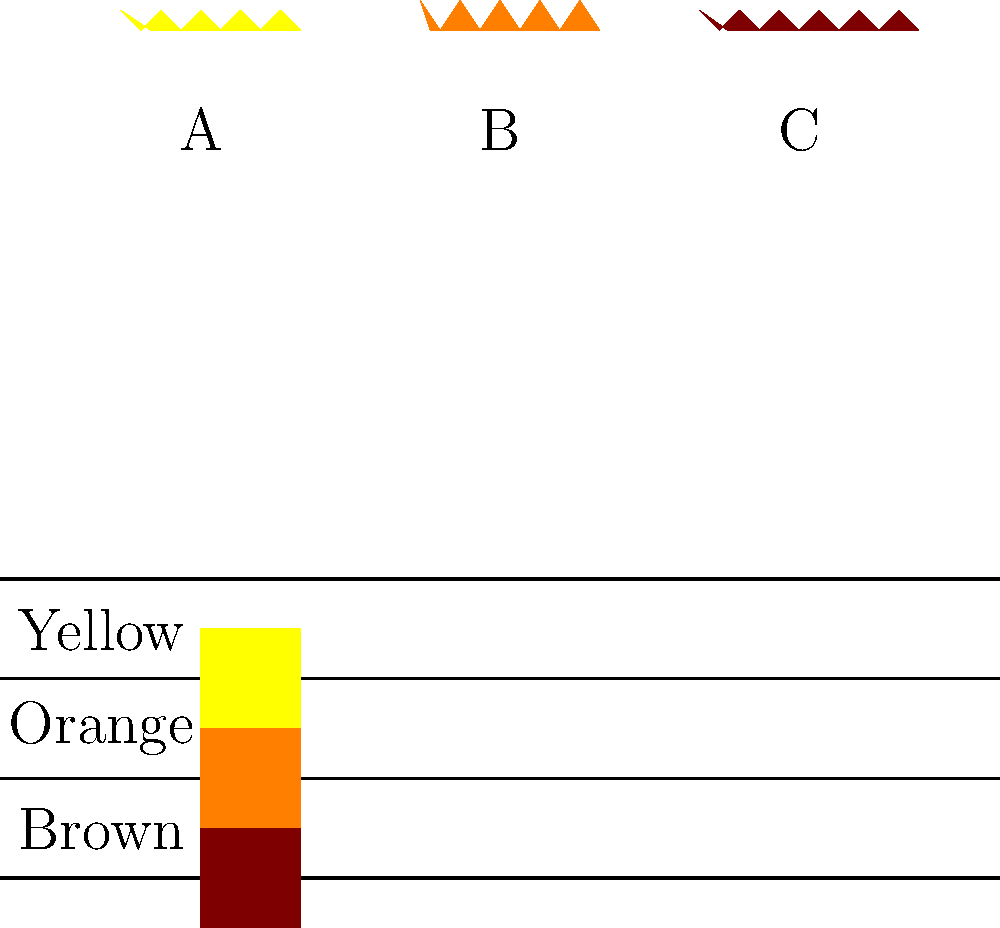Based on the visual characteristics shown in the image, which of the native bee species (A, B, or C) is most likely to be a bumble bee? To identify the bumble bee among the given native bee species, let's analyze their visual characteristics step-by-step:

1. Size: Bumble bees are generally larger than other bee species. In the image, bee B appears to be the largest among the three.

2. Body shape: Bumble bees have a robust, round body shape. Bee B has the most pronounced round shape compared to A and C.

3. Color: Bumble bees typically have a combination of black and yellow coloration, often with orange or brown bands. Bee B is colored orange, which is consistent with some bumble bee species.

4. Fuzziness: Bumble bees are known for their fuzzy appearance. While this is not explicitly shown in the silhouettes, the larger size of bee B implies a potentially fuzzier appearance.

5. Wing size: Bumble bees have relatively small wings compared to their body size. The wings are not clearly depicted in the silhouettes, but the overall body proportion of bee B is most consistent with a bumble bee.

Considering these factors, especially the larger size, rounder shape, and orange coloration, bee B most closely matches the characteristics of a bumble bee among the given options.
Answer: B 